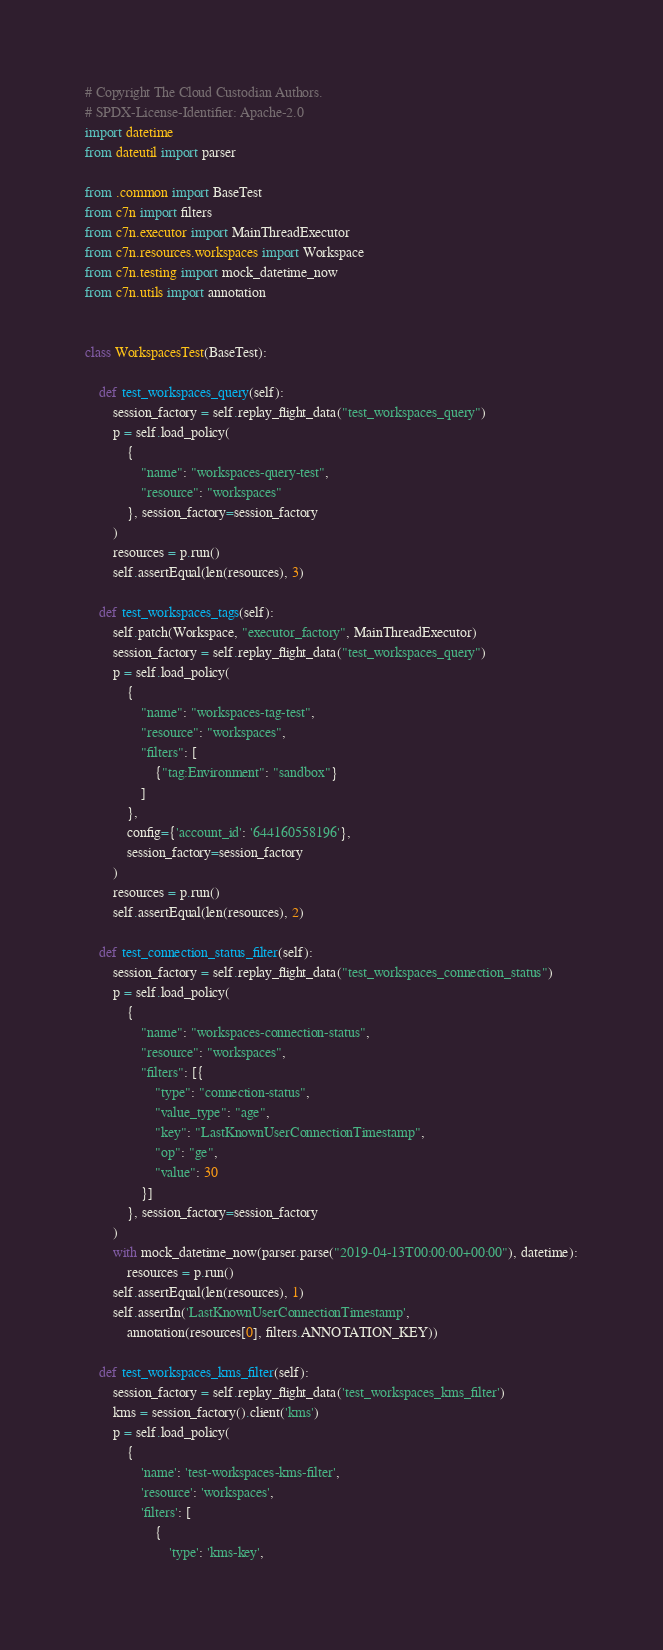<code> <loc_0><loc_0><loc_500><loc_500><_Python_># Copyright The Cloud Custodian Authors.
# SPDX-License-Identifier: Apache-2.0
import datetime
from dateutil import parser

from .common import BaseTest
from c7n import filters
from c7n.executor import MainThreadExecutor
from c7n.resources.workspaces import Workspace
from c7n.testing import mock_datetime_now
from c7n.utils import annotation


class WorkspacesTest(BaseTest):

    def test_workspaces_query(self):
        session_factory = self.replay_flight_data("test_workspaces_query")
        p = self.load_policy(
            {
                "name": "workspaces-query-test",
                "resource": "workspaces"
            }, session_factory=session_factory
        )
        resources = p.run()
        self.assertEqual(len(resources), 3)

    def test_workspaces_tags(self):
        self.patch(Workspace, "executor_factory", MainThreadExecutor)
        session_factory = self.replay_flight_data("test_workspaces_query")
        p = self.load_policy(
            {
                "name": "workspaces-tag-test",
                "resource": "workspaces",
                "filters": [
                    {"tag:Environment": "sandbox"}
                ]
            },
            config={'account_id': '644160558196'},
            session_factory=session_factory
        )
        resources = p.run()
        self.assertEqual(len(resources), 2)

    def test_connection_status_filter(self):
        session_factory = self.replay_flight_data("test_workspaces_connection_status")
        p = self.load_policy(
            {
                "name": "workspaces-connection-status",
                "resource": "workspaces",
                "filters": [{
                    "type": "connection-status",
                    "value_type": "age",
                    "key": "LastKnownUserConnectionTimestamp",
                    "op": "ge",
                    "value": 30
                }]
            }, session_factory=session_factory
        )
        with mock_datetime_now(parser.parse("2019-04-13T00:00:00+00:00"), datetime):
            resources = p.run()
        self.assertEqual(len(resources), 1)
        self.assertIn('LastKnownUserConnectionTimestamp',
            annotation(resources[0], filters.ANNOTATION_KEY))

    def test_workspaces_kms_filter(self):
        session_factory = self.replay_flight_data('test_workspaces_kms_filter')
        kms = session_factory().client('kms')
        p = self.load_policy(
            {
                'name': 'test-workspaces-kms-filter',
                'resource': 'workspaces',
                'filters': [
                    {
                        'type': 'kms-key',</code> 